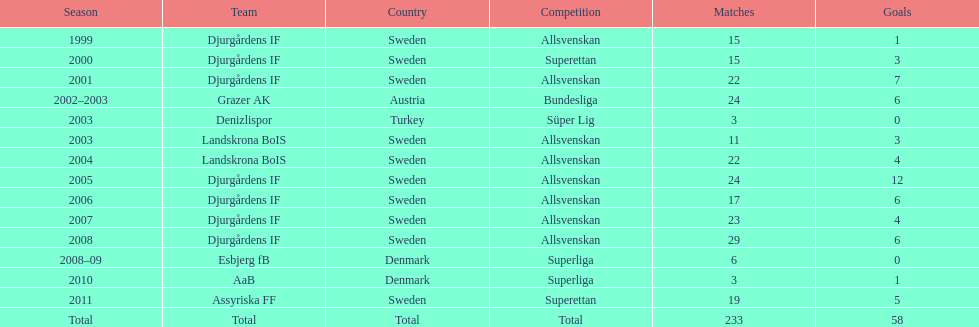In the season, how many teams played more than 20 matches? 6. 